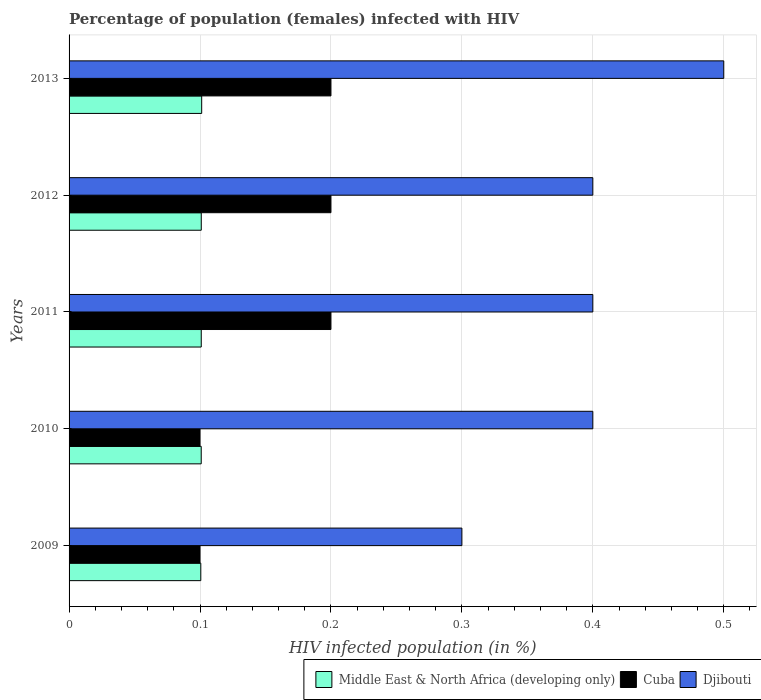How many groups of bars are there?
Your response must be concise. 5. Are the number of bars per tick equal to the number of legend labels?
Your answer should be compact. Yes. How many bars are there on the 2nd tick from the top?
Your answer should be compact. 3. What is the percentage of HIV infected female population in Middle East & North Africa (developing only) in 2012?
Give a very brief answer. 0.1. Across all years, what is the minimum percentage of HIV infected female population in Middle East & North Africa (developing only)?
Offer a very short reply. 0.1. What is the total percentage of HIV infected female population in Middle East & North Africa (developing only) in the graph?
Your answer should be very brief. 0.5. What is the difference between the percentage of HIV infected female population in Middle East & North Africa (developing only) in 2009 and that in 2011?
Provide a short and direct response. -0. What is the difference between the percentage of HIV infected female population in Djibouti in 2009 and the percentage of HIV infected female population in Middle East & North Africa (developing only) in 2011?
Ensure brevity in your answer.  0.2. What is the average percentage of HIV infected female population in Cuba per year?
Make the answer very short. 0.16. In the year 2010, what is the difference between the percentage of HIV infected female population in Djibouti and percentage of HIV infected female population in Middle East & North Africa (developing only)?
Provide a short and direct response. 0.3. Is the percentage of HIV infected female population in Middle East & North Africa (developing only) in 2011 less than that in 2012?
Keep it short and to the point. Yes. Is the difference between the percentage of HIV infected female population in Djibouti in 2010 and 2011 greater than the difference between the percentage of HIV infected female population in Middle East & North Africa (developing only) in 2010 and 2011?
Offer a very short reply. Yes. What is the difference between the highest and the second highest percentage of HIV infected female population in Djibouti?
Offer a very short reply. 0.1. In how many years, is the percentage of HIV infected female population in Djibouti greater than the average percentage of HIV infected female population in Djibouti taken over all years?
Offer a very short reply. 1. Is the sum of the percentage of HIV infected female population in Middle East & North Africa (developing only) in 2012 and 2013 greater than the maximum percentage of HIV infected female population in Cuba across all years?
Ensure brevity in your answer.  Yes. What does the 3rd bar from the top in 2009 represents?
Keep it short and to the point. Middle East & North Africa (developing only). What does the 1st bar from the bottom in 2013 represents?
Your answer should be very brief. Middle East & North Africa (developing only). Is it the case that in every year, the sum of the percentage of HIV infected female population in Middle East & North Africa (developing only) and percentage of HIV infected female population in Cuba is greater than the percentage of HIV infected female population in Djibouti?
Your response must be concise. No. What is the difference between two consecutive major ticks on the X-axis?
Your answer should be very brief. 0.1. Does the graph contain grids?
Provide a succinct answer. Yes. Where does the legend appear in the graph?
Your response must be concise. Bottom right. What is the title of the graph?
Provide a succinct answer. Percentage of population (females) infected with HIV. Does "Montenegro" appear as one of the legend labels in the graph?
Make the answer very short. No. What is the label or title of the X-axis?
Keep it short and to the point. HIV infected population (in %). What is the label or title of the Y-axis?
Offer a very short reply. Years. What is the HIV infected population (in %) of Middle East & North Africa (developing only) in 2009?
Provide a short and direct response. 0.1. What is the HIV infected population (in %) of Middle East & North Africa (developing only) in 2010?
Provide a succinct answer. 0.1. What is the HIV infected population (in %) of Cuba in 2010?
Ensure brevity in your answer.  0.1. What is the HIV infected population (in %) in Djibouti in 2010?
Provide a short and direct response. 0.4. What is the HIV infected population (in %) of Middle East & North Africa (developing only) in 2011?
Make the answer very short. 0.1. What is the HIV infected population (in %) of Cuba in 2011?
Keep it short and to the point. 0.2. What is the HIV infected population (in %) in Middle East & North Africa (developing only) in 2012?
Provide a succinct answer. 0.1. What is the HIV infected population (in %) in Djibouti in 2012?
Your answer should be very brief. 0.4. What is the HIV infected population (in %) of Middle East & North Africa (developing only) in 2013?
Provide a succinct answer. 0.1. What is the HIV infected population (in %) of Cuba in 2013?
Your answer should be compact. 0.2. What is the HIV infected population (in %) in Djibouti in 2013?
Provide a short and direct response. 0.5. Across all years, what is the maximum HIV infected population (in %) in Middle East & North Africa (developing only)?
Ensure brevity in your answer.  0.1. Across all years, what is the maximum HIV infected population (in %) in Djibouti?
Provide a succinct answer. 0.5. Across all years, what is the minimum HIV infected population (in %) of Middle East & North Africa (developing only)?
Provide a succinct answer. 0.1. Across all years, what is the minimum HIV infected population (in %) in Cuba?
Offer a terse response. 0.1. Across all years, what is the minimum HIV infected population (in %) of Djibouti?
Ensure brevity in your answer.  0.3. What is the total HIV infected population (in %) of Middle East & North Africa (developing only) in the graph?
Keep it short and to the point. 0.5. What is the total HIV infected population (in %) of Cuba in the graph?
Your answer should be very brief. 0.8. What is the difference between the HIV infected population (in %) of Middle East & North Africa (developing only) in 2009 and that in 2010?
Your answer should be very brief. -0. What is the difference between the HIV infected population (in %) of Middle East & North Africa (developing only) in 2009 and that in 2011?
Give a very brief answer. -0. What is the difference between the HIV infected population (in %) in Cuba in 2009 and that in 2011?
Keep it short and to the point. -0.1. What is the difference between the HIV infected population (in %) of Djibouti in 2009 and that in 2011?
Keep it short and to the point. -0.1. What is the difference between the HIV infected population (in %) in Middle East & North Africa (developing only) in 2009 and that in 2012?
Provide a succinct answer. -0. What is the difference between the HIV infected population (in %) of Cuba in 2009 and that in 2012?
Offer a very short reply. -0.1. What is the difference between the HIV infected population (in %) of Middle East & North Africa (developing only) in 2009 and that in 2013?
Ensure brevity in your answer.  -0. What is the difference between the HIV infected population (in %) of Cuba in 2009 and that in 2013?
Provide a short and direct response. -0.1. What is the difference between the HIV infected population (in %) in Djibouti in 2009 and that in 2013?
Give a very brief answer. -0.2. What is the difference between the HIV infected population (in %) of Middle East & North Africa (developing only) in 2010 and that in 2011?
Offer a terse response. -0. What is the difference between the HIV infected population (in %) of Djibouti in 2010 and that in 2011?
Offer a very short reply. 0. What is the difference between the HIV infected population (in %) in Middle East & North Africa (developing only) in 2010 and that in 2012?
Offer a very short reply. -0. What is the difference between the HIV infected population (in %) in Middle East & North Africa (developing only) in 2010 and that in 2013?
Keep it short and to the point. -0. What is the difference between the HIV infected population (in %) in Djibouti in 2010 and that in 2013?
Provide a short and direct response. -0.1. What is the difference between the HIV infected population (in %) in Middle East & North Africa (developing only) in 2011 and that in 2012?
Ensure brevity in your answer.  -0. What is the difference between the HIV infected population (in %) of Cuba in 2011 and that in 2012?
Make the answer very short. 0. What is the difference between the HIV infected population (in %) in Middle East & North Africa (developing only) in 2011 and that in 2013?
Your answer should be very brief. -0. What is the difference between the HIV infected population (in %) of Djibouti in 2011 and that in 2013?
Give a very brief answer. -0.1. What is the difference between the HIV infected population (in %) of Middle East & North Africa (developing only) in 2012 and that in 2013?
Give a very brief answer. -0. What is the difference between the HIV infected population (in %) of Middle East & North Africa (developing only) in 2009 and the HIV infected population (in %) of Cuba in 2010?
Provide a succinct answer. 0. What is the difference between the HIV infected population (in %) of Middle East & North Africa (developing only) in 2009 and the HIV infected population (in %) of Djibouti in 2010?
Ensure brevity in your answer.  -0.3. What is the difference between the HIV infected population (in %) of Cuba in 2009 and the HIV infected population (in %) of Djibouti in 2010?
Make the answer very short. -0.3. What is the difference between the HIV infected population (in %) in Middle East & North Africa (developing only) in 2009 and the HIV infected population (in %) in Cuba in 2011?
Your answer should be very brief. -0.1. What is the difference between the HIV infected population (in %) in Middle East & North Africa (developing only) in 2009 and the HIV infected population (in %) in Djibouti in 2011?
Provide a short and direct response. -0.3. What is the difference between the HIV infected population (in %) of Cuba in 2009 and the HIV infected population (in %) of Djibouti in 2011?
Provide a short and direct response. -0.3. What is the difference between the HIV infected population (in %) of Middle East & North Africa (developing only) in 2009 and the HIV infected population (in %) of Cuba in 2012?
Provide a short and direct response. -0.1. What is the difference between the HIV infected population (in %) of Middle East & North Africa (developing only) in 2009 and the HIV infected population (in %) of Djibouti in 2012?
Give a very brief answer. -0.3. What is the difference between the HIV infected population (in %) of Middle East & North Africa (developing only) in 2009 and the HIV infected population (in %) of Cuba in 2013?
Provide a short and direct response. -0.1. What is the difference between the HIV infected population (in %) of Middle East & North Africa (developing only) in 2009 and the HIV infected population (in %) of Djibouti in 2013?
Ensure brevity in your answer.  -0.4. What is the difference between the HIV infected population (in %) in Cuba in 2009 and the HIV infected population (in %) in Djibouti in 2013?
Ensure brevity in your answer.  -0.4. What is the difference between the HIV infected population (in %) of Middle East & North Africa (developing only) in 2010 and the HIV infected population (in %) of Cuba in 2011?
Ensure brevity in your answer.  -0.1. What is the difference between the HIV infected population (in %) in Middle East & North Africa (developing only) in 2010 and the HIV infected population (in %) in Djibouti in 2011?
Keep it short and to the point. -0.3. What is the difference between the HIV infected population (in %) in Middle East & North Africa (developing only) in 2010 and the HIV infected population (in %) in Cuba in 2012?
Your answer should be compact. -0.1. What is the difference between the HIV infected population (in %) of Middle East & North Africa (developing only) in 2010 and the HIV infected population (in %) of Djibouti in 2012?
Offer a terse response. -0.3. What is the difference between the HIV infected population (in %) of Middle East & North Africa (developing only) in 2010 and the HIV infected population (in %) of Cuba in 2013?
Provide a short and direct response. -0.1. What is the difference between the HIV infected population (in %) in Middle East & North Africa (developing only) in 2010 and the HIV infected population (in %) in Djibouti in 2013?
Your response must be concise. -0.4. What is the difference between the HIV infected population (in %) in Cuba in 2010 and the HIV infected population (in %) in Djibouti in 2013?
Offer a very short reply. -0.4. What is the difference between the HIV infected population (in %) of Middle East & North Africa (developing only) in 2011 and the HIV infected population (in %) of Cuba in 2012?
Provide a short and direct response. -0.1. What is the difference between the HIV infected population (in %) in Middle East & North Africa (developing only) in 2011 and the HIV infected population (in %) in Djibouti in 2012?
Offer a very short reply. -0.3. What is the difference between the HIV infected population (in %) in Middle East & North Africa (developing only) in 2011 and the HIV infected population (in %) in Cuba in 2013?
Offer a very short reply. -0.1. What is the difference between the HIV infected population (in %) in Middle East & North Africa (developing only) in 2011 and the HIV infected population (in %) in Djibouti in 2013?
Ensure brevity in your answer.  -0.4. What is the difference between the HIV infected population (in %) in Cuba in 2011 and the HIV infected population (in %) in Djibouti in 2013?
Your answer should be compact. -0.3. What is the difference between the HIV infected population (in %) in Middle East & North Africa (developing only) in 2012 and the HIV infected population (in %) in Cuba in 2013?
Your answer should be very brief. -0.1. What is the difference between the HIV infected population (in %) of Middle East & North Africa (developing only) in 2012 and the HIV infected population (in %) of Djibouti in 2013?
Offer a terse response. -0.4. What is the average HIV infected population (in %) in Middle East & North Africa (developing only) per year?
Offer a terse response. 0.1. What is the average HIV infected population (in %) in Cuba per year?
Provide a short and direct response. 0.16. What is the average HIV infected population (in %) of Djibouti per year?
Your response must be concise. 0.4. In the year 2009, what is the difference between the HIV infected population (in %) in Middle East & North Africa (developing only) and HIV infected population (in %) in Cuba?
Provide a short and direct response. 0. In the year 2009, what is the difference between the HIV infected population (in %) in Middle East & North Africa (developing only) and HIV infected population (in %) in Djibouti?
Your response must be concise. -0.2. In the year 2009, what is the difference between the HIV infected population (in %) in Cuba and HIV infected population (in %) in Djibouti?
Keep it short and to the point. -0.2. In the year 2010, what is the difference between the HIV infected population (in %) of Middle East & North Africa (developing only) and HIV infected population (in %) of Cuba?
Offer a very short reply. 0. In the year 2010, what is the difference between the HIV infected population (in %) of Middle East & North Africa (developing only) and HIV infected population (in %) of Djibouti?
Give a very brief answer. -0.3. In the year 2011, what is the difference between the HIV infected population (in %) in Middle East & North Africa (developing only) and HIV infected population (in %) in Cuba?
Your response must be concise. -0.1. In the year 2011, what is the difference between the HIV infected population (in %) in Middle East & North Africa (developing only) and HIV infected population (in %) in Djibouti?
Provide a short and direct response. -0.3. In the year 2012, what is the difference between the HIV infected population (in %) in Middle East & North Africa (developing only) and HIV infected population (in %) in Cuba?
Make the answer very short. -0.1. In the year 2012, what is the difference between the HIV infected population (in %) of Middle East & North Africa (developing only) and HIV infected population (in %) of Djibouti?
Offer a very short reply. -0.3. In the year 2012, what is the difference between the HIV infected population (in %) of Cuba and HIV infected population (in %) of Djibouti?
Offer a terse response. -0.2. In the year 2013, what is the difference between the HIV infected population (in %) in Middle East & North Africa (developing only) and HIV infected population (in %) in Cuba?
Offer a terse response. -0.1. In the year 2013, what is the difference between the HIV infected population (in %) in Middle East & North Africa (developing only) and HIV infected population (in %) in Djibouti?
Provide a short and direct response. -0.4. What is the ratio of the HIV infected population (in %) in Middle East & North Africa (developing only) in 2009 to that in 2010?
Offer a terse response. 1. What is the ratio of the HIV infected population (in %) of Cuba in 2009 to that in 2010?
Your answer should be compact. 1. What is the ratio of the HIV infected population (in %) of Djibouti in 2009 to that in 2010?
Offer a very short reply. 0.75. What is the ratio of the HIV infected population (in %) of Middle East & North Africa (developing only) in 2009 to that in 2011?
Give a very brief answer. 1. What is the ratio of the HIV infected population (in %) of Djibouti in 2009 to that in 2011?
Provide a short and direct response. 0.75. What is the ratio of the HIV infected population (in %) of Middle East & North Africa (developing only) in 2009 to that in 2012?
Make the answer very short. 1. What is the ratio of the HIV infected population (in %) of Cuba in 2009 to that in 2012?
Offer a very short reply. 0.5. What is the ratio of the HIV infected population (in %) of Djibouti in 2009 to that in 2013?
Provide a short and direct response. 0.6. What is the ratio of the HIV infected population (in %) in Middle East & North Africa (developing only) in 2010 to that in 2011?
Offer a very short reply. 1. What is the ratio of the HIV infected population (in %) of Djibouti in 2010 to that in 2011?
Provide a short and direct response. 1. What is the ratio of the HIV infected population (in %) of Middle East & North Africa (developing only) in 2010 to that in 2013?
Offer a very short reply. 1. What is the ratio of the HIV infected population (in %) in Middle East & North Africa (developing only) in 2011 to that in 2012?
Ensure brevity in your answer.  1. What is the ratio of the HIV infected population (in %) in Cuba in 2011 to that in 2012?
Ensure brevity in your answer.  1. What is the ratio of the HIV infected population (in %) in Djibouti in 2011 to that in 2012?
Offer a very short reply. 1. What is the ratio of the HIV infected population (in %) of Djibouti in 2011 to that in 2013?
Ensure brevity in your answer.  0.8. What is the ratio of the HIV infected population (in %) in Djibouti in 2012 to that in 2013?
Your response must be concise. 0.8. What is the difference between the highest and the second highest HIV infected population (in %) in Cuba?
Offer a very short reply. 0. What is the difference between the highest and the second highest HIV infected population (in %) in Djibouti?
Keep it short and to the point. 0.1. What is the difference between the highest and the lowest HIV infected population (in %) in Middle East & North Africa (developing only)?
Your response must be concise. 0. What is the difference between the highest and the lowest HIV infected population (in %) of Cuba?
Offer a terse response. 0.1. 